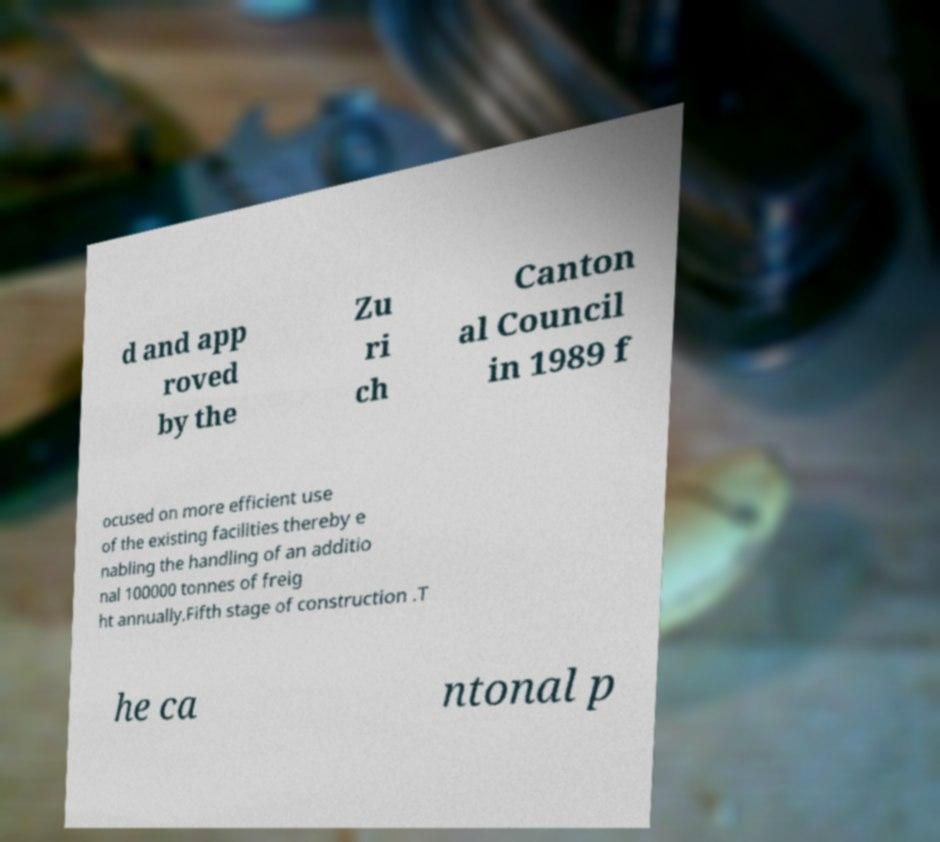Can you read and provide the text displayed in the image?This photo seems to have some interesting text. Can you extract and type it out for me? d and app roved by the Zu ri ch Canton al Council in 1989 f ocused on more efficient use of the existing facilities thereby e nabling the handling of an additio nal 100000 tonnes of freig ht annually.Fifth stage of construction .T he ca ntonal p 